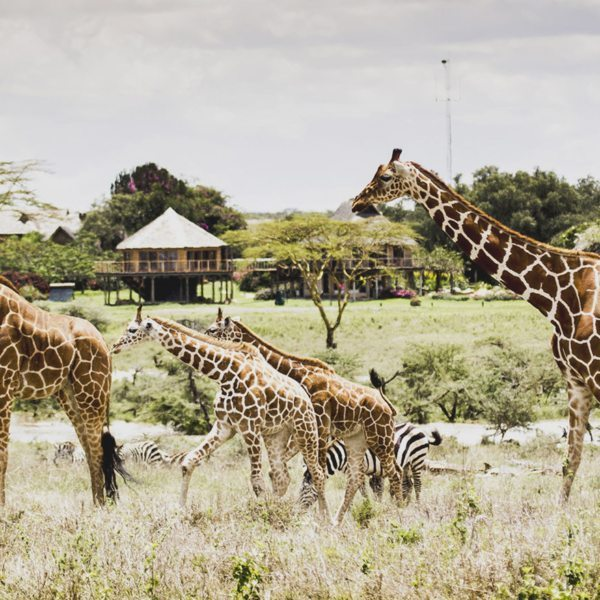Considering the structure in the background, what could be its purpose in this setting? The wooden structure in the background, elevated on stilts, is likely designed as an observation deck or safari lodge. Its raised position provides an excellent vantage point for guests to safely observe wildlife, such as the giraffes and zebras in the image, without disturbing the animals. This setup is typical in wildlife reserves and safari parks, allowing visitors to enjoy the natural habitat while maintaining a safe distance from the animals. Additionally, the structure’s design blends with the environment, promoting eco-friendly tourism. 